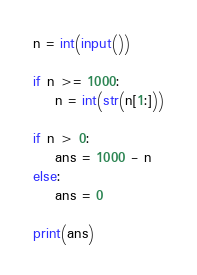Convert code to text. <code><loc_0><loc_0><loc_500><loc_500><_Python_>n = int(input())

if n >= 1000:
    n = int(str(n[1:]))

if n > 0:
    ans = 1000 - n
else:
    ans = 0

print(ans)</code> 